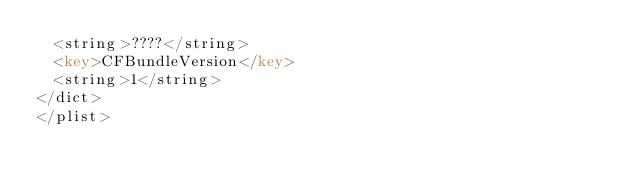Convert code to text. <code><loc_0><loc_0><loc_500><loc_500><_XML_>	<string>????</string>
	<key>CFBundleVersion</key>
	<string>1</string>
</dict>
</plist>
</code> 